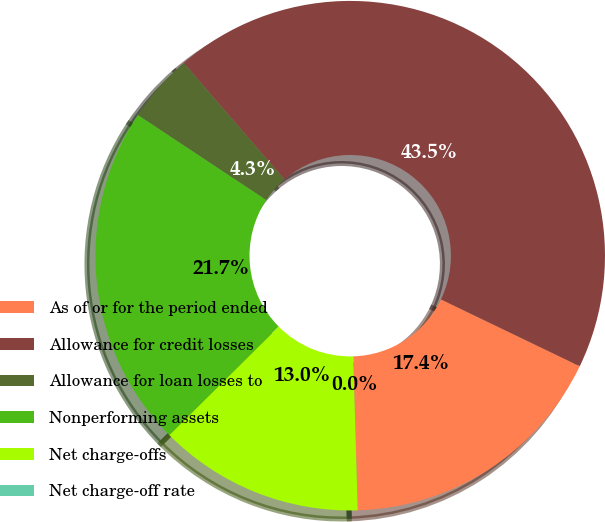Convert chart to OTSL. <chart><loc_0><loc_0><loc_500><loc_500><pie_chart><fcel>As of or for the period ended<fcel>Allowance for credit losses<fcel>Allowance for loan losses to<fcel>Nonperforming assets<fcel>Net charge-offs<fcel>Net charge-off rate<nl><fcel>17.39%<fcel>43.48%<fcel>4.35%<fcel>21.74%<fcel>13.04%<fcel>0.0%<nl></chart> 